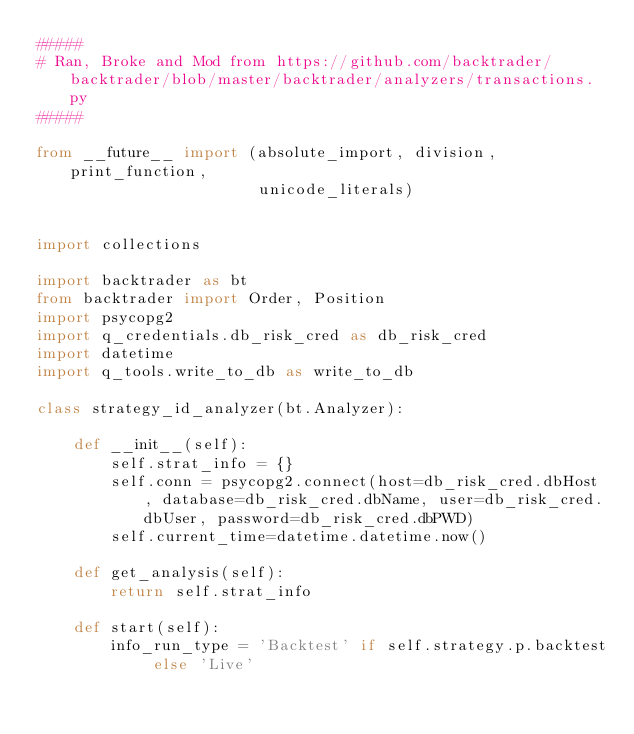Convert code to text. <code><loc_0><loc_0><loc_500><loc_500><_Python_>#####
# Ran, Broke and Mod from https://github.com/backtrader/backtrader/blob/master/backtrader/analyzers/transactions.py
#####

from __future__ import (absolute_import, division, print_function,
                        unicode_literals)


import collections

import backtrader as bt
from backtrader import Order, Position
import psycopg2
import q_credentials.db_risk_cred as db_risk_cred
import datetime
import q_tools.write_to_db as write_to_db

class strategy_id_analyzer(bt.Analyzer):

    def __init__(self):
        self.strat_info = {}
        self.conn = psycopg2.connect(host=db_risk_cred.dbHost , database=db_risk_cred.dbName, user=db_risk_cred.dbUser, password=db_risk_cred.dbPWD)
        self.current_time=datetime.datetime.now()

    def get_analysis(self):
        return self.strat_info

    def start(self):
        info_run_type = 'Backtest' if self.strategy.p.backtest else 'Live'</code> 